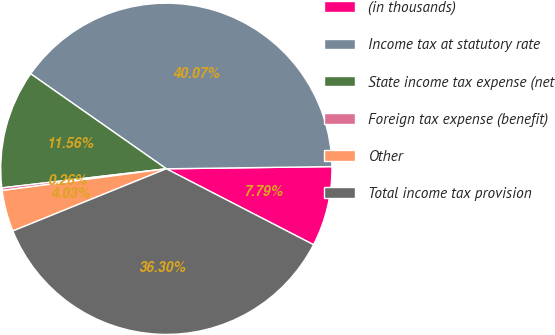Convert chart. <chart><loc_0><loc_0><loc_500><loc_500><pie_chart><fcel>(in thousands)<fcel>Income tax at statutory rate<fcel>State income tax expense (net<fcel>Foreign tax expense (benefit)<fcel>Other<fcel>Total income tax provision<nl><fcel>7.79%<fcel>40.07%<fcel>11.56%<fcel>0.26%<fcel>4.03%<fcel>36.3%<nl></chart> 